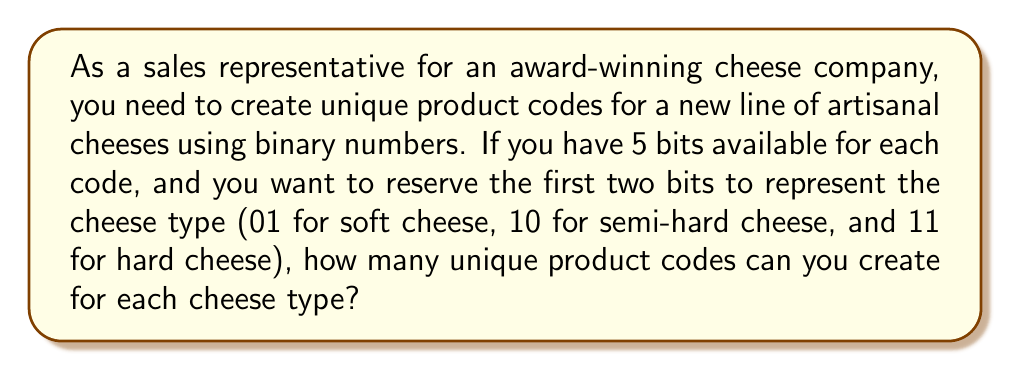Teach me how to tackle this problem. To solve this problem, we need to follow these steps:

1. Understand the binary system:
   In binary, each digit (bit) can be either 0 or 1.

2. Analyze the given information:
   - We have 5 bits in total for each code.
   - The first two bits are reserved for cheese type:
     01 = soft cheese
     10 = semi-hard cheese
     11 = hard cheese

3. Determine the number of available bits:
   Since the first two bits are used for cheese type, we have 3 bits left for unique product codes within each cheese type.

4. Calculate the number of possible combinations:
   With 3 bits, we can create $2^3 = 8$ unique combinations.

   This is because each bit has 2 possibilities (0 or 1), and we have 3 bits:
   $2 \times 2 \times 2 = 8$

   We can represent this mathematically as:

   $$\text{Number of combinations} = 2^n$$

   Where $n$ is the number of available bits (in this case, 3).

5. Verify the result:
   We can list all possible 3-bit combinations to confirm:
   000, 001, 010, 011, 100, 101, 110, 111

Therefore, for each cheese type, we can create 8 unique product codes using the remaining 3 bits.
Answer: 8 unique product codes for each cheese type 